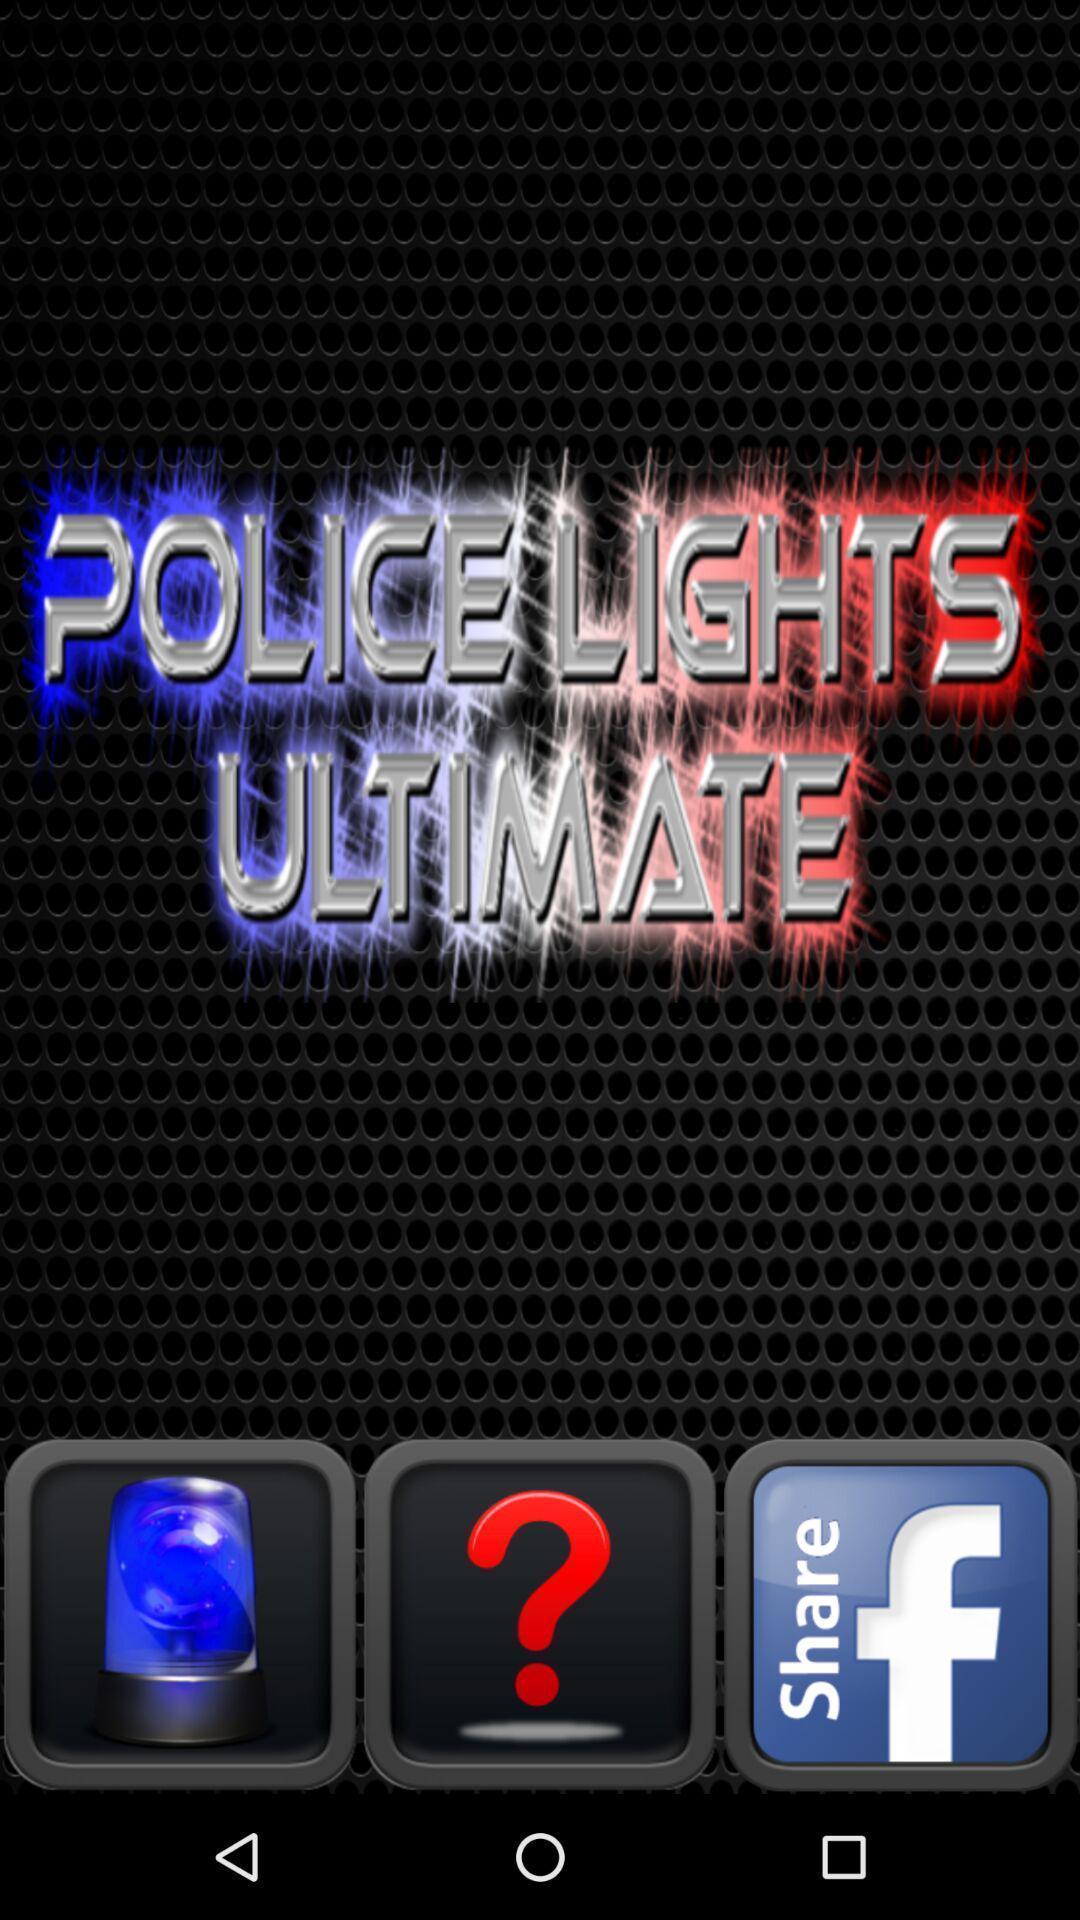Tell me what you see in this picture. Screen shows police light with share option. 